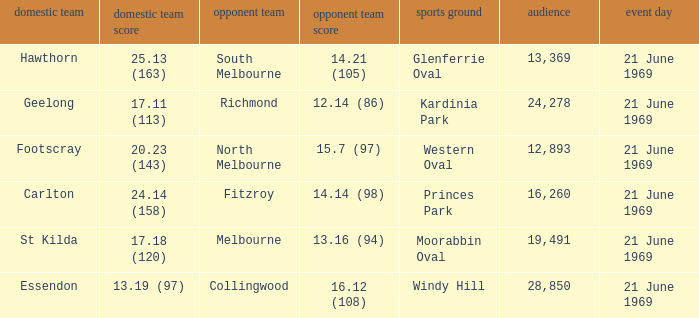When was there a game at Kardinia Park? 21 June 1969. 